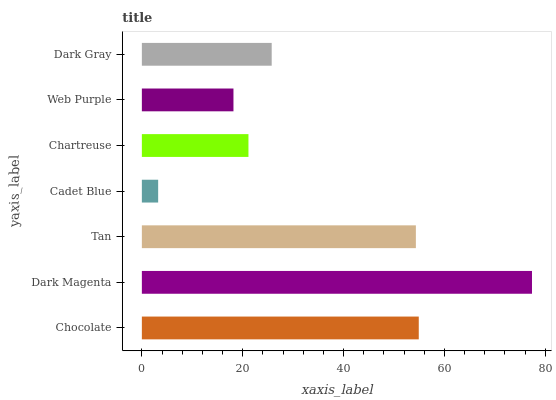Is Cadet Blue the minimum?
Answer yes or no. Yes. Is Dark Magenta the maximum?
Answer yes or no. Yes. Is Tan the minimum?
Answer yes or no. No. Is Tan the maximum?
Answer yes or no. No. Is Dark Magenta greater than Tan?
Answer yes or no. Yes. Is Tan less than Dark Magenta?
Answer yes or no. Yes. Is Tan greater than Dark Magenta?
Answer yes or no. No. Is Dark Magenta less than Tan?
Answer yes or no. No. Is Dark Gray the high median?
Answer yes or no. Yes. Is Dark Gray the low median?
Answer yes or no. Yes. Is Web Purple the high median?
Answer yes or no. No. Is Cadet Blue the low median?
Answer yes or no. No. 